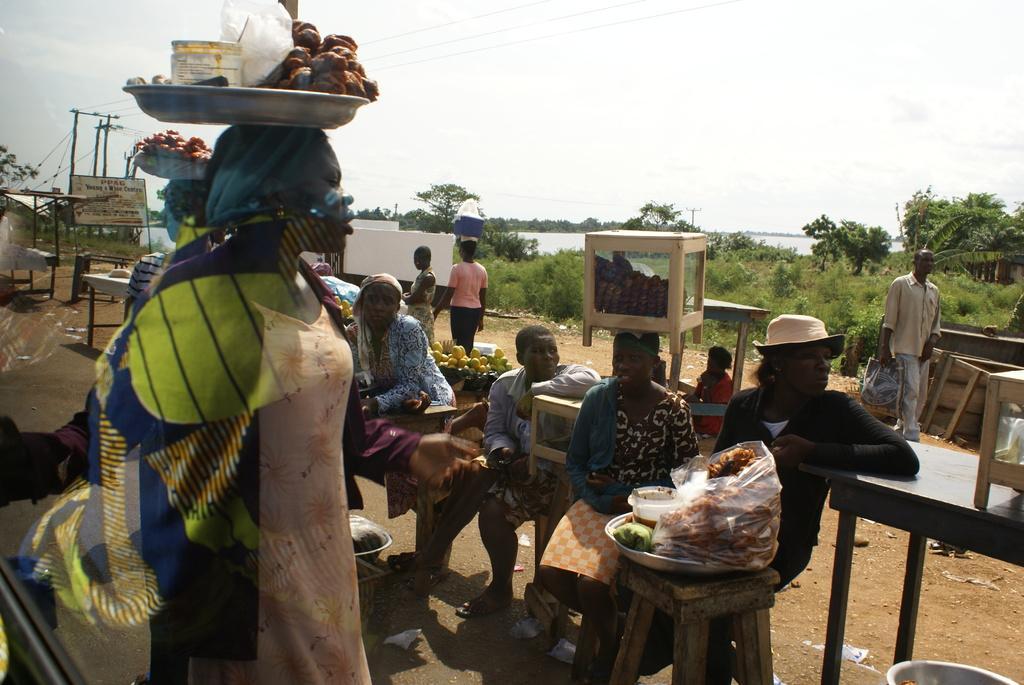Could you give a brief overview of what you see in this image? In this image there are group of persons who are selling products in the market and at the left side of the image there is a board and current poles and at the right side of the image there are trees and the background cloudy sky. 